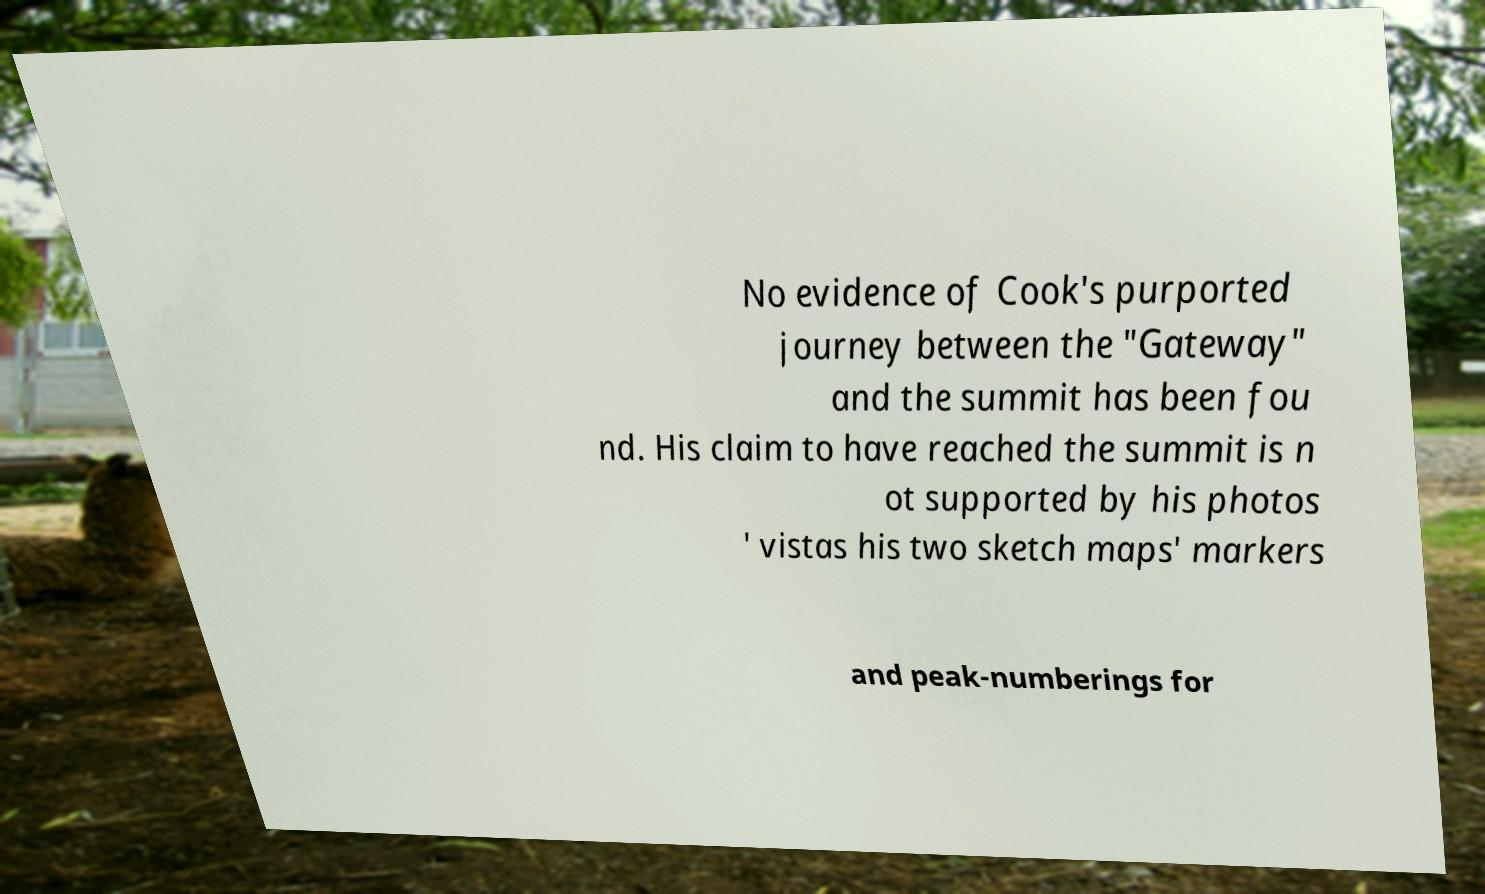Please identify and transcribe the text found in this image. No evidence of Cook's purported journey between the "Gateway" and the summit has been fou nd. His claim to have reached the summit is n ot supported by his photos ' vistas his two sketch maps' markers and peak-numberings for 